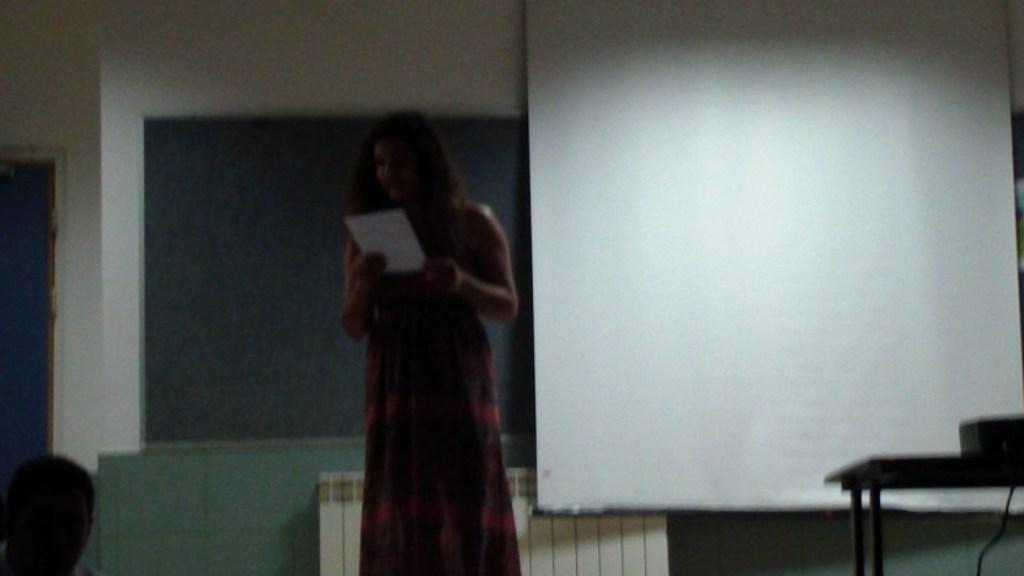Describe this image in one or two sentences. In this image we can see two persons, one of them is holding a paper, behind them there is a screen, also we can see the wall, and there is a projector on the table. 